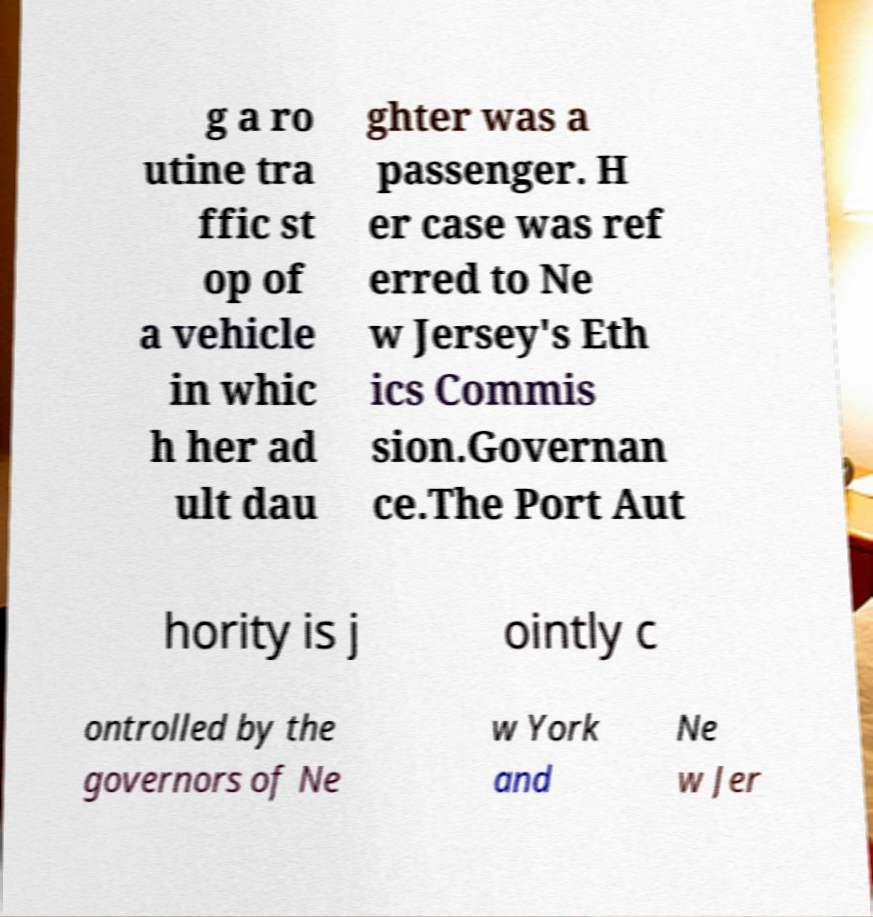Could you extract and type out the text from this image? g a ro utine tra ffic st op of a vehicle in whic h her ad ult dau ghter was a passenger. H er case was ref erred to Ne w Jersey's Eth ics Commis sion.Governan ce.The Port Aut hority is j ointly c ontrolled by the governors of Ne w York and Ne w Jer 